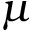Convert formula to latex. <formula><loc_0><loc_0><loc_500><loc_500>\mu</formula> 